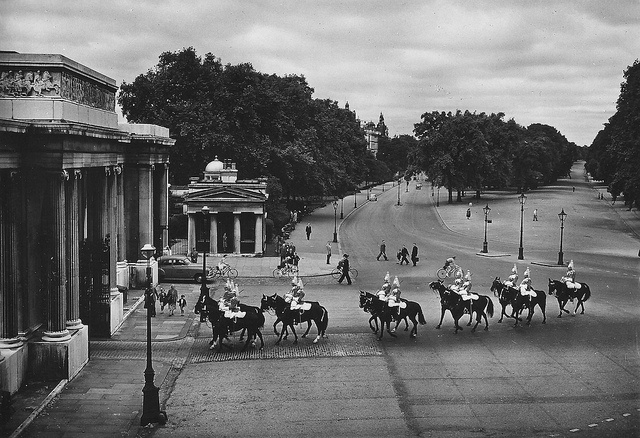Describe the objects in this image and their specific colors. I can see people in darkgray, black, gray, and lightgray tones, horse in darkgray, black, lightgray, and gray tones, horse in darkgray, black, gray, and lightgray tones, car in darkgray, black, gray, and lightgray tones, and horse in darkgray, black, gray, and lightgray tones in this image. 